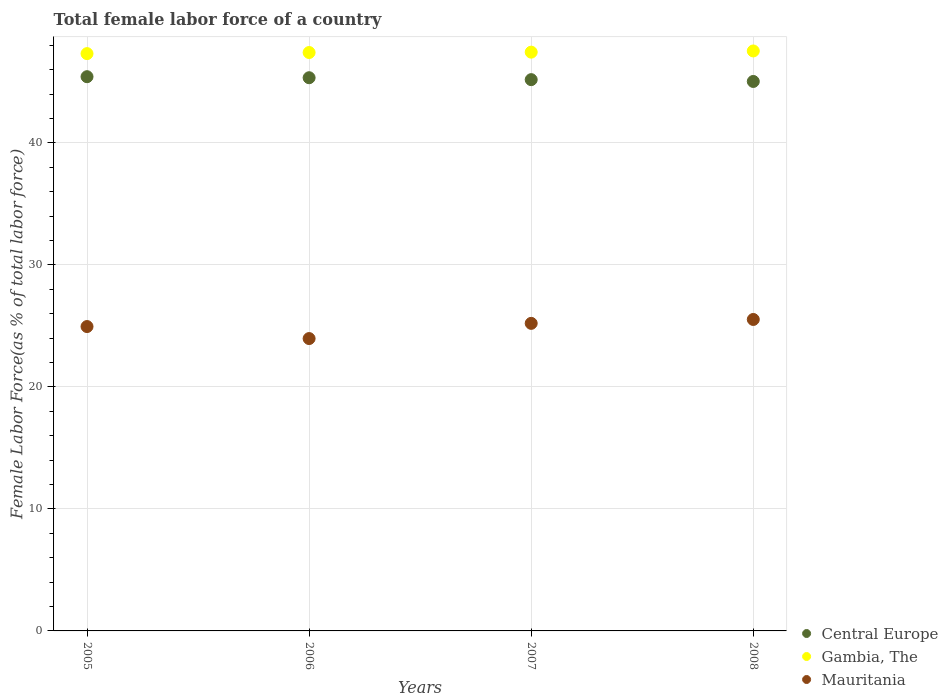How many different coloured dotlines are there?
Your response must be concise. 3. Is the number of dotlines equal to the number of legend labels?
Offer a very short reply. Yes. What is the percentage of female labor force in Central Europe in 2008?
Offer a terse response. 45.03. Across all years, what is the maximum percentage of female labor force in Gambia, The?
Your answer should be compact. 47.53. Across all years, what is the minimum percentage of female labor force in Central Europe?
Give a very brief answer. 45.03. In which year was the percentage of female labor force in Mauritania minimum?
Provide a short and direct response. 2006. What is the total percentage of female labor force in Mauritania in the graph?
Offer a very short reply. 99.64. What is the difference between the percentage of female labor force in Mauritania in 2006 and that in 2008?
Provide a short and direct response. -1.57. What is the difference between the percentage of female labor force in Mauritania in 2007 and the percentage of female labor force in Central Europe in 2008?
Provide a short and direct response. -19.83. What is the average percentage of female labor force in Central Europe per year?
Offer a very short reply. 45.24. In the year 2005, what is the difference between the percentage of female labor force in Mauritania and percentage of female labor force in Gambia, The?
Ensure brevity in your answer.  -22.37. What is the ratio of the percentage of female labor force in Central Europe in 2006 to that in 2007?
Provide a succinct answer. 1. What is the difference between the highest and the second highest percentage of female labor force in Mauritania?
Provide a short and direct response. 0.32. What is the difference between the highest and the lowest percentage of female labor force in Gambia, The?
Provide a succinct answer. 0.22. Is the percentage of female labor force in Central Europe strictly less than the percentage of female labor force in Mauritania over the years?
Offer a terse response. No. How many dotlines are there?
Keep it short and to the point. 3. How many years are there in the graph?
Your response must be concise. 4. Does the graph contain grids?
Offer a very short reply. Yes. How are the legend labels stacked?
Keep it short and to the point. Vertical. What is the title of the graph?
Provide a short and direct response. Total female labor force of a country. Does "Haiti" appear as one of the legend labels in the graph?
Provide a succinct answer. No. What is the label or title of the Y-axis?
Give a very brief answer. Female Labor Force(as % of total labor force). What is the Female Labor Force(as % of total labor force) in Central Europe in 2005?
Your answer should be very brief. 45.42. What is the Female Labor Force(as % of total labor force) in Gambia, The in 2005?
Offer a very short reply. 47.32. What is the Female Labor Force(as % of total labor force) of Mauritania in 2005?
Give a very brief answer. 24.95. What is the Female Labor Force(as % of total labor force) in Central Europe in 2006?
Offer a terse response. 45.34. What is the Female Labor Force(as % of total labor force) of Gambia, The in 2006?
Provide a short and direct response. 47.41. What is the Female Labor Force(as % of total labor force) of Mauritania in 2006?
Your answer should be very brief. 23.96. What is the Female Labor Force(as % of total labor force) in Central Europe in 2007?
Give a very brief answer. 45.18. What is the Female Labor Force(as % of total labor force) of Gambia, The in 2007?
Ensure brevity in your answer.  47.44. What is the Female Labor Force(as % of total labor force) in Mauritania in 2007?
Provide a short and direct response. 25.21. What is the Female Labor Force(as % of total labor force) of Central Europe in 2008?
Provide a succinct answer. 45.03. What is the Female Labor Force(as % of total labor force) of Gambia, The in 2008?
Offer a very short reply. 47.53. What is the Female Labor Force(as % of total labor force) in Mauritania in 2008?
Give a very brief answer. 25.53. Across all years, what is the maximum Female Labor Force(as % of total labor force) in Central Europe?
Your answer should be very brief. 45.42. Across all years, what is the maximum Female Labor Force(as % of total labor force) of Gambia, The?
Keep it short and to the point. 47.53. Across all years, what is the maximum Female Labor Force(as % of total labor force) of Mauritania?
Provide a succinct answer. 25.53. Across all years, what is the minimum Female Labor Force(as % of total labor force) of Central Europe?
Your response must be concise. 45.03. Across all years, what is the minimum Female Labor Force(as % of total labor force) in Gambia, The?
Provide a succinct answer. 47.32. Across all years, what is the minimum Female Labor Force(as % of total labor force) of Mauritania?
Provide a succinct answer. 23.96. What is the total Female Labor Force(as % of total labor force) of Central Europe in the graph?
Your answer should be compact. 180.98. What is the total Female Labor Force(as % of total labor force) in Gambia, The in the graph?
Your response must be concise. 189.69. What is the total Female Labor Force(as % of total labor force) in Mauritania in the graph?
Offer a very short reply. 99.64. What is the difference between the Female Labor Force(as % of total labor force) of Central Europe in 2005 and that in 2006?
Provide a short and direct response. 0.08. What is the difference between the Female Labor Force(as % of total labor force) of Gambia, The in 2005 and that in 2006?
Make the answer very short. -0.09. What is the difference between the Female Labor Force(as % of total labor force) in Mauritania in 2005 and that in 2006?
Your answer should be very brief. 0.98. What is the difference between the Female Labor Force(as % of total labor force) in Central Europe in 2005 and that in 2007?
Offer a terse response. 0.24. What is the difference between the Female Labor Force(as % of total labor force) of Gambia, The in 2005 and that in 2007?
Make the answer very short. -0.12. What is the difference between the Female Labor Force(as % of total labor force) in Mauritania in 2005 and that in 2007?
Make the answer very short. -0.26. What is the difference between the Female Labor Force(as % of total labor force) of Central Europe in 2005 and that in 2008?
Ensure brevity in your answer.  0.39. What is the difference between the Female Labor Force(as % of total labor force) in Gambia, The in 2005 and that in 2008?
Provide a succinct answer. -0.22. What is the difference between the Female Labor Force(as % of total labor force) of Mauritania in 2005 and that in 2008?
Offer a terse response. -0.58. What is the difference between the Female Labor Force(as % of total labor force) of Central Europe in 2006 and that in 2007?
Offer a terse response. 0.16. What is the difference between the Female Labor Force(as % of total labor force) in Gambia, The in 2006 and that in 2007?
Ensure brevity in your answer.  -0.03. What is the difference between the Female Labor Force(as % of total labor force) in Mauritania in 2006 and that in 2007?
Give a very brief answer. -1.25. What is the difference between the Female Labor Force(as % of total labor force) of Central Europe in 2006 and that in 2008?
Your answer should be compact. 0.31. What is the difference between the Female Labor Force(as % of total labor force) in Gambia, The in 2006 and that in 2008?
Make the answer very short. -0.13. What is the difference between the Female Labor Force(as % of total labor force) in Mauritania in 2006 and that in 2008?
Your response must be concise. -1.57. What is the difference between the Female Labor Force(as % of total labor force) of Central Europe in 2007 and that in 2008?
Make the answer very short. 0.15. What is the difference between the Female Labor Force(as % of total labor force) of Gambia, The in 2007 and that in 2008?
Offer a very short reply. -0.1. What is the difference between the Female Labor Force(as % of total labor force) of Mauritania in 2007 and that in 2008?
Ensure brevity in your answer.  -0.32. What is the difference between the Female Labor Force(as % of total labor force) of Central Europe in 2005 and the Female Labor Force(as % of total labor force) of Gambia, The in 2006?
Offer a very short reply. -1.98. What is the difference between the Female Labor Force(as % of total labor force) of Central Europe in 2005 and the Female Labor Force(as % of total labor force) of Mauritania in 2006?
Provide a short and direct response. 21.46. What is the difference between the Female Labor Force(as % of total labor force) in Gambia, The in 2005 and the Female Labor Force(as % of total labor force) in Mauritania in 2006?
Offer a terse response. 23.35. What is the difference between the Female Labor Force(as % of total labor force) in Central Europe in 2005 and the Female Labor Force(as % of total labor force) in Gambia, The in 2007?
Give a very brief answer. -2.01. What is the difference between the Female Labor Force(as % of total labor force) of Central Europe in 2005 and the Female Labor Force(as % of total labor force) of Mauritania in 2007?
Offer a very short reply. 20.22. What is the difference between the Female Labor Force(as % of total labor force) of Gambia, The in 2005 and the Female Labor Force(as % of total labor force) of Mauritania in 2007?
Your answer should be very brief. 22.11. What is the difference between the Female Labor Force(as % of total labor force) in Central Europe in 2005 and the Female Labor Force(as % of total labor force) in Gambia, The in 2008?
Your response must be concise. -2.11. What is the difference between the Female Labor Force(as % of total labor force) of Central Europe in 2005 and the Female Labor Force(as % of total labor force) of Mauritania in 2008?
Give a very brief answer. 19.9. What is the difference between the Female Labor Force(as % of total labor force) in Gambia, The in 2005 and the Female Labor Force(as % of total labor force) in Mauritania in 2008?
Your response must be concise. 21.79. What is the difference between the Female Labor Force(as % of total labor force) of Central Europe in 2006 and the Female Labor Force(as % of total labor force) of Gambia, The in 2007?
Make the answer very short. -2.1. What is the difference between the Female Labor Force(as % of total labor force) in Central Europe in 2006 and the Female Labor Force(as % of total labor force) in Mauritania in 2007?
Offer a very short reply. 20.13. What is the difference between the Female Labor Force(as % of total labor force) in Gambia, The in 2006 and the Female Labor Force(as % of total labor force) in Mauritania in 2007?
Your response must be concise. 22.2. What is the difference between the Female Labor Force(as % of total labor force) in Central Europe in 2006 and the Female Labor Force(as % of total labor force) in Gambia, The in 2008?
Offer a terse response. -2.19. What is the difference between the Female Labor Force(as % of total labor force) of Central Europe in 2006 and the Female Labor Force(as % of total labor force) of Mauritania in 2008?
Give a very brief answer. 19.81. What is the difference between the Female Labor Force(as % of total labor force) of Gambia, The in 2006 and the Female Labor Force(as % of total labor force) of Mauritania in 2008?
Make the answer very short. 21.88. What is the difference between the Female Labor Force(as % of total labor force) of Central Europe in 2007 and the Female Labor Force(as % of total labor force) of Gambia, The in 2008?
Your response must be concise. -2.35. What is the difference between the Female Labor Force(as % of total labor force) of Central Europe in 2007 and the Female Labor Force(as % of total labor force) of Mauritania in 2008?
Give a very brief answer. 19.66. What is the difference between the Female Labor Force(as % of total labor force) in Gambia, The in 2007 and the Female Labor Force(as % of total labor force) in Mauritania in 2008?
Ensure brevity in your answer.  21.91. What is the average Female Labor Force(as % of total labor force) in Central Europe per year?
Give a very brief answer. 45.24. What is the average Female Labor Force(as % of total labor force) of Gambia, The per year?
Your answer should be very brief. 47.42. What is the average Female Labor Force(as % of total labor force) in Mauritania per year?
Provide a short and direct response. 24.91. In the year 2005, what is the difference between the Female Labor Force(as % of total labor force) in Central Europe and Female Labor Force(as % of total labor force) in Gambia, The?
Your answer should be compact. -1.89. In the year 2005, what is the difference between the Female Labor Force(as % of total labor force) in Central Europe and Female Labor Force(as % of total labor force) in Mauritania?
Provide a succinct answer. 20.48. In the year 2005, what is the difference between the Female Labor Force(as % of total labor force) of Gambia, The and Female Labor Force(as % of total labor force) of Mauritania?
Give a very brief answer. 22.37. In the year 2006, what is the difference between the Female Labor Force(as % of total labor force) in Central Europe and Female Labor Force(as % of total labor force) in Gambia, The?
Provide a short and direct response. -2.07. In the year 2006, what is the difference between the Female Labor Force(as % of total labor force) in Central Europe and Female Labor Force(as % of total labor force) in Mauritania?
Give a very brief answer. 21.38. In the year 2006, what is the difference between the Female Labor Force(as % of total labor force) of Gambia, The and Female Labor Force(as % of total labor force) of Mauritania?
Offer a very short reply. 23.44. In the year 2007, what is the difference between the Female Labor Force(as % of total labor force) of Central Europe and Female Labor Force(as % of total labor force) of Gambia, The?
Offer a terse response. -2.25. In the year 2007, what is the difference between the Female Labor Force(as % of total labor force) of Central Europe and Female Labor Force(as % of total labor force) of Mauritania?
Give a very brief answer. 19.97. In the year 2007, what is the difference between the Female Labor Force(as % of total labor force) of Gambia, The and Female Labor Force(as % of total labor force) of Mauritania?
Provide a succinct answer. 22.23. In the year 2008, what is the difference between the Female Labor Force(as % of total labor force) in Central Europe and Female Labor Force(as % of total labor force) in Gambia, The?
Your response must be concise. -2.5. In the year 2008, what is the difference between the Female Labor Force(as % of total labor force) of Central Europe and Female Labor Force(as % of total labor force) of Mauritania?
Keep it short and to the point. 19.51. In the year 2008, what is the difference between the Female Labor Force(as % of total labor force) in Gambia, The and Female Labor Force(as % of total labor force) in Mauritania?
Your answer should be compact. 22.01. What is the ratio of the Female Labor Force(as % of total labor force) in Gambia, The in 2005 to that in 2006?
Offer a very short reply. 1. What is the ratio of the Female Labor Force(as % of total labor force) of Mauritania in 2005 to that in 2006?
Offer a terse response. 1.04. What is the ratio of the Female Labor Force(as % of total labor force) in Central Europe in 2005 to that in 2007?
Offer a very short reply. 1.01. What is the ratio of the Female Labor Force(as % of total labor force) of Gambia, The in 2005 to that in 2007?
Give a very brief answer. 1. What is the ratio of the Female Labor Force(as % of total labor force) in Mauritania in 2005 to that in 2007?
Ensure brevity in your answer.  0.99. What is the ratio of the Female Labor Force(as % of total labor force) in Central Europe in 2005 to that in 2008?
Give a very brief answer. 1.01. What is the ratio of the Female Labor Force(as % of total labor force) of Gambia, The in 2005 to that in 2008?
Ensure brevity in your answer.  1. What is the ratio of the Female Labor Force(as % of total labor force) in Mauritania in 2005 to that in 2008?
Provide a succinct answer. 0.98. What is the ratio of the Female Labor Force(as % of total labor force) of Mauritania in 2006 to that in 2007?
Your answer should be very brief. 0.95. What is the ratio of the Female Labor Force(as % of total labor force) of Central Europe in 2006 to that in 2008?
Offer a very short reply. 1.01. What is the ratio of the Female Labor Force(as % of total labor force) in Gambia, The in 2006 to that in 2008?
Make the answer very short. 1. What is the ratio of the Female Labor Force(as % of total labor force) in Mauritania in 2006 to that in 2008?
Provide a succinct answer. 0.94. What is the ratio of the Female Labor Force(as % of total labor force) in Central Europe in 2007 to that in 2008?
Your answer should be very brief. 1. What is the ratio of the Female Labor Force(as % of total labor force) of Mauritania in 2007 to that in 2008?
Your answer should be compact. 0.99. What is the difference between the highest and the second highest Female Labor Force(as % of total labor force) in Central Europe?
Your response must be concise. 0.08. What is the difference between the highest and the second highest Female Labor Force(as % of total labor force) in Gambia, The?
Ensure brevity in your answer.  0.1. What is the difference between the highest and the second highest Female Labor Force(as % of total labor force) in Mauritania?
Provide a succinct answer. 0.32. What is the difference between the highest and the lowest Female Labor Force(as % of total labor force) of Central Europe?
Your response must be concise. 0.39. What is the difference between the highest and the lowest Female Labor Force(as % of total labor force) in Gambia, The?
Make the answer very short. 0.22. What is the difference between the highest and the lowest Female Labor Force(as % of total labor force) of Mauritania?
Give a very brief answer. 1.57. 